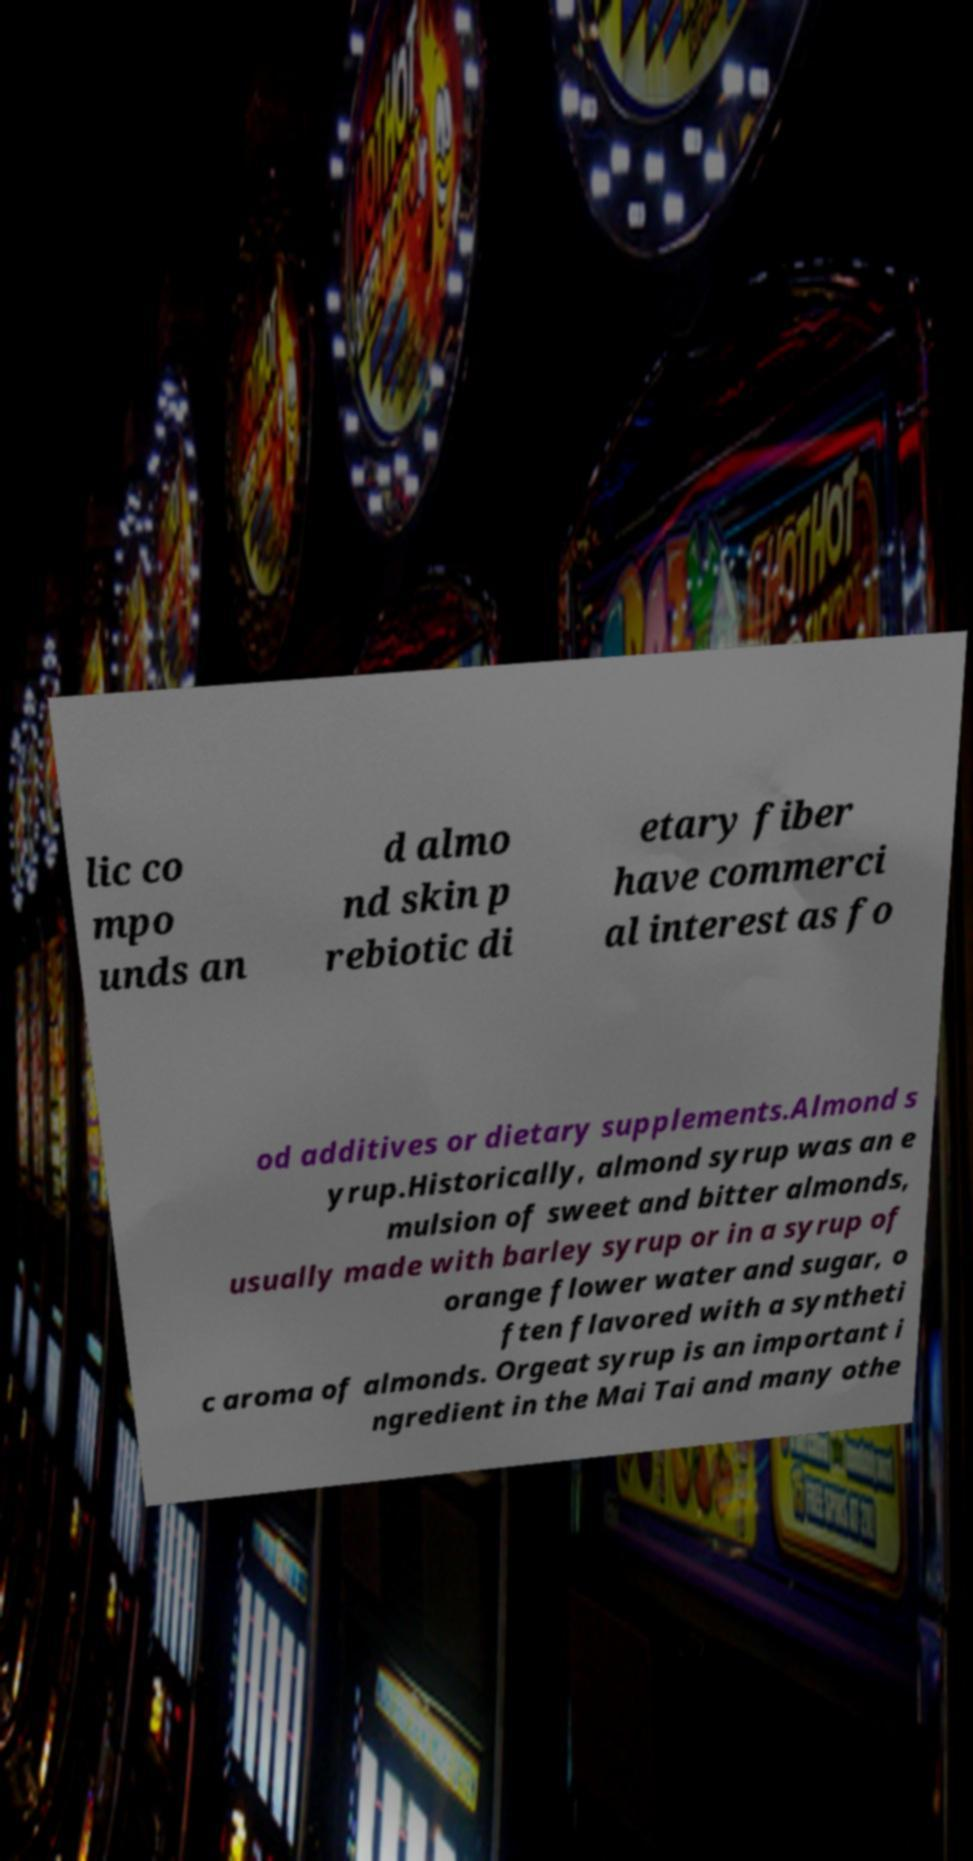Please read and relay the text visible in this image. What does it say? lic co mpo unds an d almo nd skin p rebiotic di etary fiber have commerci al interest as fo od additives or dietary supplements.Almond s yrup.Historically, almond syrup was an e mulsion of sweet and bitter almonds, usually made with barley syrup or in a syrup of orange flower water and sugar, o ften flavored with a syntheti c aroma of almonds. Orgeat syrup is an important i ngredient in the Mai Tai and many othe 